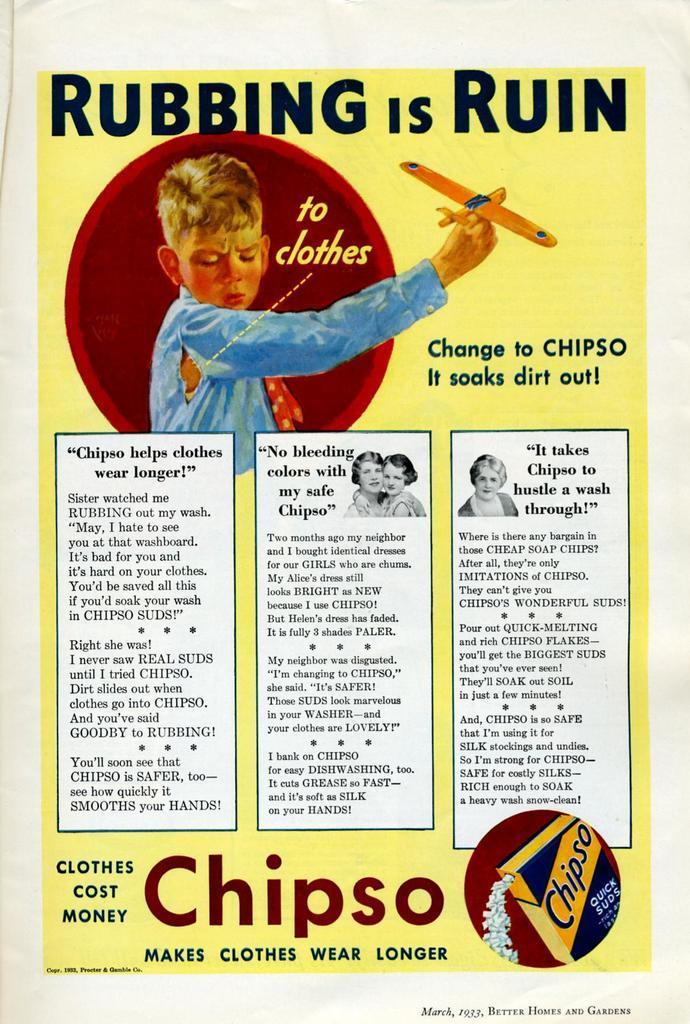<image>
Create a compact narrative representing the image presented. Picture of a Chipso rubbing is ruin sign about clothes 